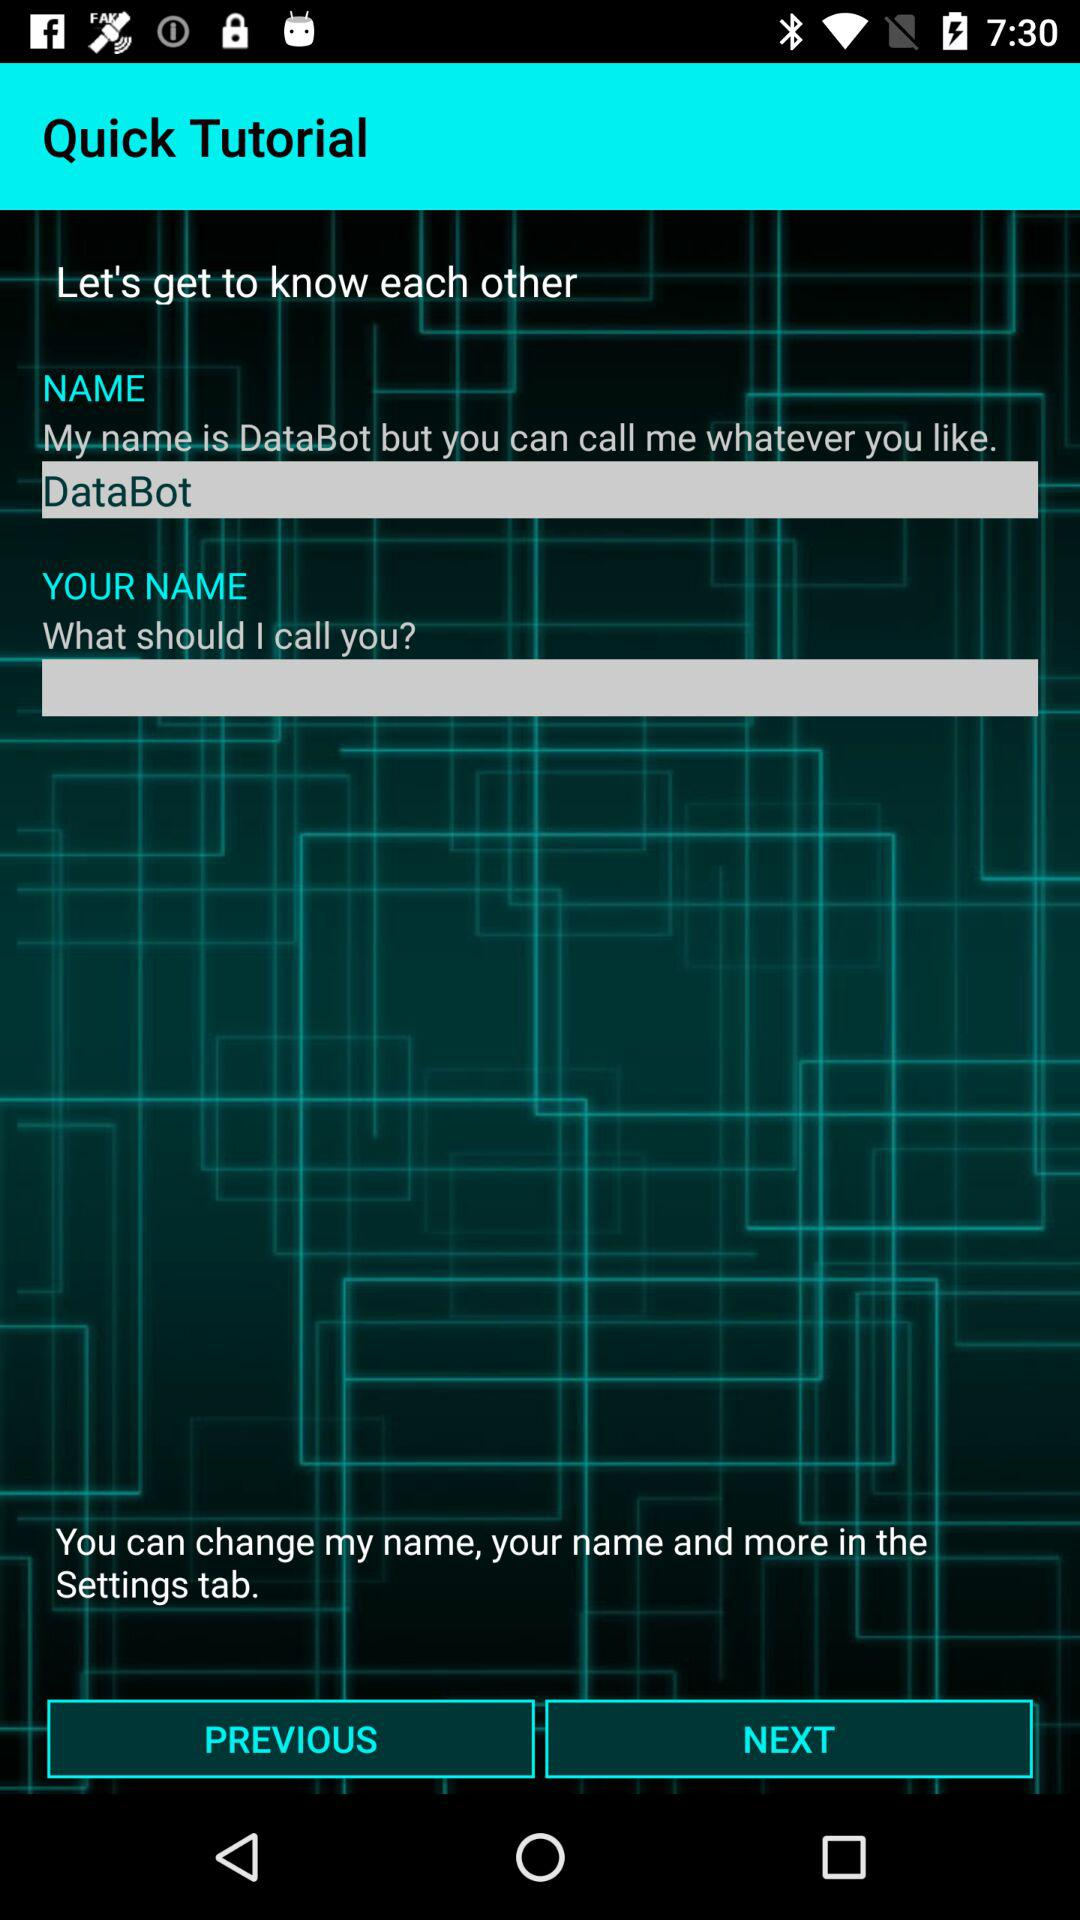What is the name? The name is DataBot. 